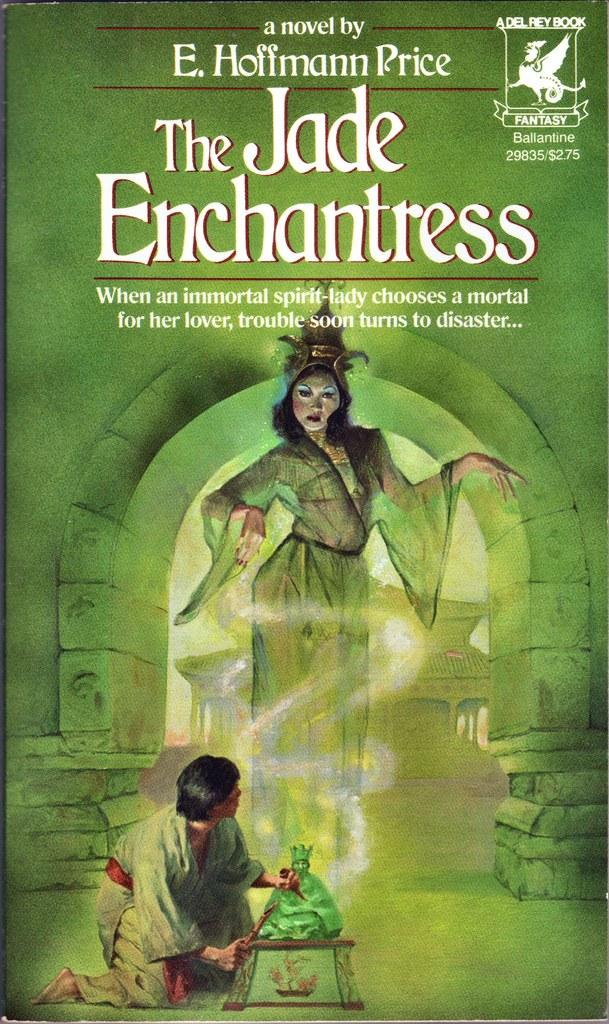What is featured on the poster in the image? The poster contains a picture of people wearing clothes. What architectural feature can be seen in the image? There is an arch in the image. What type of artwork is present in the image? There is a sculpture in the image. What can be read or deciphered in the image? There is text visible in the image. What type of frame is around the owl in the image? There is no owl present in the image, so there is no frame around an owl. 